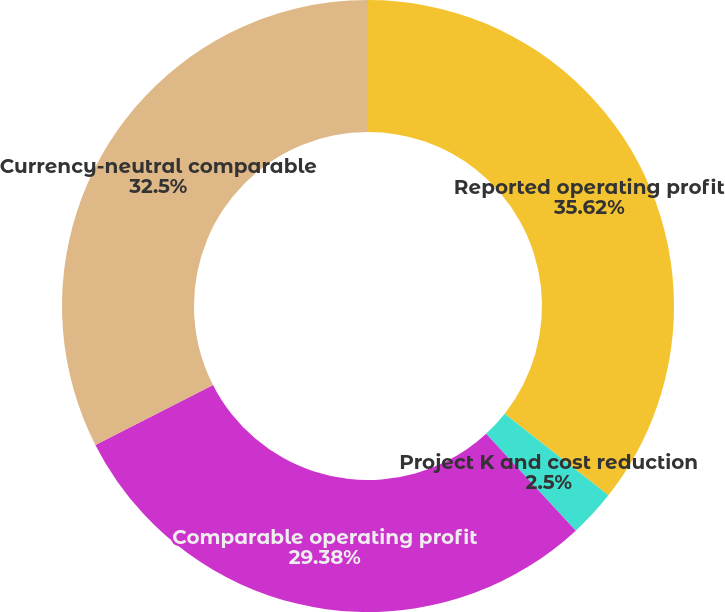Convert chart to OTSL. <chart><loc_0><loc_0><loc_500><loc_500><pie_chart><fcel>Reported operating profit<fcel>Project K and cost reduction<fcel>Comparable operating profit<fcel>Currency-neutral comparable<nl><fcel>35.62%<fcel>2.5%<fcel>29.38%<fcel>32.5%<nl></chart> 